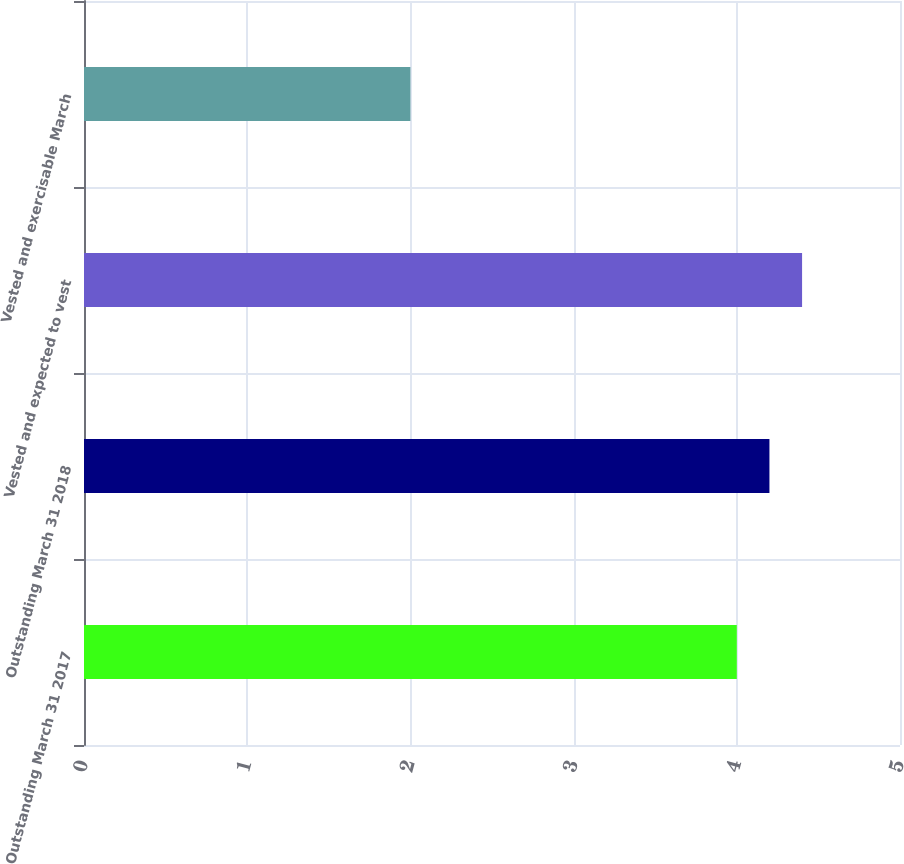Convert chart to OTSL. <chart><loc_0><loc_0><loc_500><loc_500><bar_chart><fcel>Outstanding March 31 2017<fcel>Outstanding March 31 2018<fcel>Vested and expected to vest<fcel>Vested and exercisable March<nl><fcel>4<fcel>4.2<fcel>4.4<fcel>2<nl></chart> 